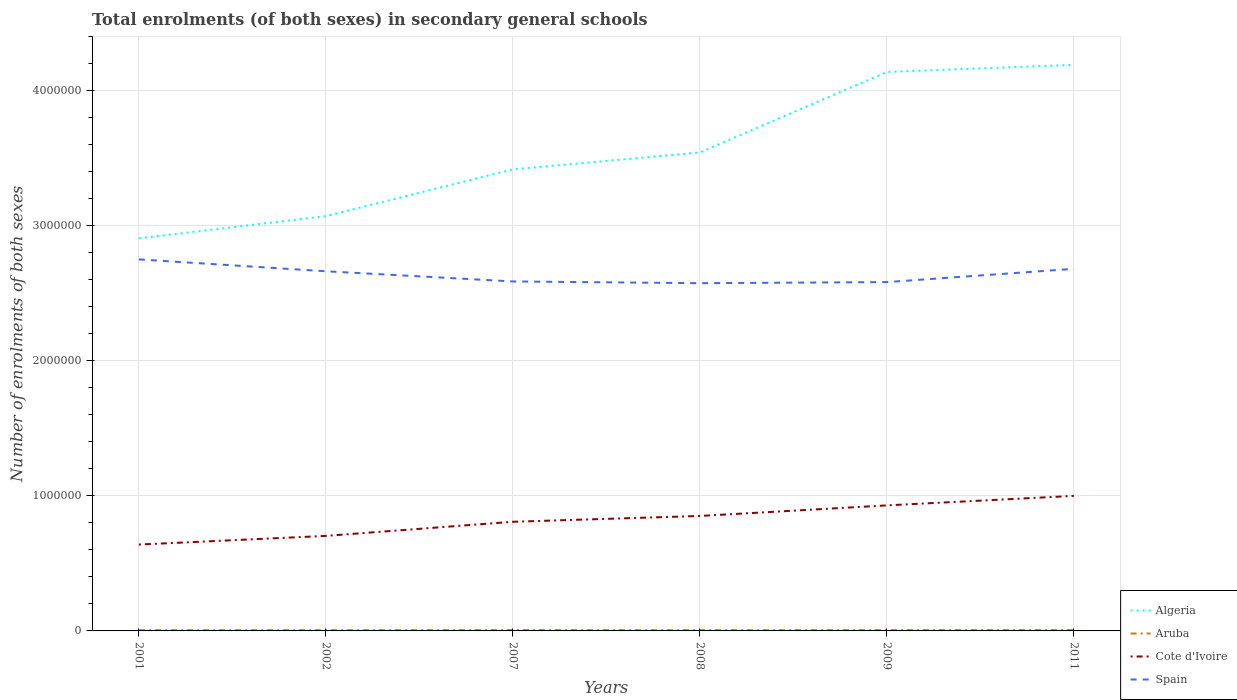Across all years, what is the maximum number of enrolments in secondary schools in Algeria?
Keep it short and to the point. 2.91e+06. In which year was the number of enrolments in secondary schools in Spain maximum?
Give a very brief answer. 2008. What is the total number of enrolments in secondary schools in Cote d'Ivoire in the graph?
Give a very brief answer. -6.43e+04. What is the difference between the highest and the second highest number of enrolments in secondary schools in Cote d'Ivoire?
Make the answer very short. 3.60e+05. How many years are there in the graph?
Make the answer very short. 6. Does the graph contain any zero values?
Provide a succinct answer. No. How many legend labels are there?
Give a very brief answer. 4. What is the title of the graph?
Keep it short and to the point. Total enrolments (of both sexes) in secondary general schools. What is the label or title of the X-axis?
Your answer should be very brief. Years. What is the label or title of the Y-axis?
Provide a short and direct response. Number of enrolments of both sexes. What is the Number of enrolments of both sexes of Algeria in 2001?
Keep it short and to the point. 2.91e+06. What is the Number of enrolments of both sexes of Aruba in 2001?
Give a very brief answer. 5352. What is the Number of enrolments of both sexes of Cote d'Ivoire in 2001?
Keep it short and to the point. 6.39e+05. What is the Number of enrolments of both sexes of Spain in 2001?
Your response must be concise. 2.75e+06. What is the Number of enrolments of both sexes of Algeria in 2002?
Keep it short and to the point. 3.07e+06. What is the Number of enrolments of both sexes in Aruba in 2002?
Ensure brevity in your answer.  5559. What is the Number of enrolments of both sexes in Cote d'Ivoire in 2002?
Your answer should be very brief. 7.04e+05. What is the Number of enrolments of both sexes in Spain in 2002?
Your answer should be compact. 2.66e+06. What is the Number of enrolments of both sexes in Algeria in 2007?
Ensure brevity in your answer.  3.42e+06. What is the Number of enrolments of both sexes in Aruba in 2007?
Give a very brief answer. 6339. What is the Number of enrolments of both sexes of Cote d'Ivoire in 2007?
Your response must be concise. 8.08e+05. What is the Number of enrolments of both sexes of Spain in 2007?
Provide a short and direct response. 2.59e+06. What is the Number of enrolments of both sexes of Algeria in 2008?
Give a very brief answer. 3.54e+06. What is the Number of enrolments of both sexes in Aruba in 2008?
Your response must be concise. 5921. What is the Number of enrolments of both sexes of Cote d'Ivoire in 2008?
Your answer should be very brief. 8.51e+05. What is the Number of enrolments of both sexes in Spain in 2008?
Provide a short and direct response. 2.57e+06. What is the Number of enrolments of both sexes in Algeria in 2009?
Ensure brevity in your answer.  4.14e+06. What is the Number of enrolments of both sexes of Aruba in 2009?
Give a very brief answer. 6201. What is the Number of enrolments of both sexes of Cote d'Ivoire in 2009?
Ensure brevity in your answer.  9.30e+05. What is the Number of enrolments of both sexes in Spain in 2009?
Your answer should be compact. 2.58e+06. What is the Number of enrolments of both sexes of Algeria in 2011?
Ensure brevity in your answer.  4.19e+06. What is the Number of enrolments of both sexes in Aruba in 2011?
Ensure brevity in your answer.  6281. What is the Number of enrolments of both sexes in Cote d'Ivoire in 2011?
Keep it short and to the point. 1.00e+06. What is the Number of enrolments of both sexes in Spain in 2011?
Your answer should be compact. 2.68e+06. Across all years, what is the maximum Number of enrolments of both sexes in Algeria?
Keep it short and to the point. 4.19e+06. Across all years, what is the maximum Number of enrolments of both sexes in Aruba?
Your answer should be compact. 6339. Across all years, what is the maximum Number of enrolments of both sexes of Cote d'Ivoire?
Offer a terse response. 1.00e+06. Across all years, what is the maximum Number of enrolments of both sexes of Spain?
Offer a terse response. 2.75e+06. Across all years, what is the minimum Number of enrolments of both sexes of Algeria?
Make the answer very short. 2.91e+06. Across all years, what is the minimum Number of enrolments of both sexes in Aruba?
Offer a terse response. 5352. Across all years, what is the minimum Number of enrolments of both sexes in Cote d'Ivoire?
Provide a short and direct response. 6.39e+05. Across all years, what is the minimum Number of enrolments of both sexes in Spain?
Offer a very short reply. 2.57e+06. What is the total Number of enrolments of both sexes of Algeria in the graph?
Your response must be concise. 2.13e+07. What is the total Number of enrolments of both sexes of Aruba in the graph?
Your answer should be compact. 3.57e+04. What is the total Number of enrolments of both sexes of Cote d'Ivoire in the graph?
Give a very brief answer. 4.93e+06. What is the total Number of enrolments of both sexes in Spain in the graph?
Your response must be concise. 1.58e+07. What is the difference between the Number of enrolments of both sexes in Algeria in 2001 and that in 2002?
Keep it short and to the point. -1.65e+05. What is the difference between the Number of enrolments of both sexes in Aruba in 2001 and that in 2002?
Offer a terse response. -207. What is the difference between the Number of enrolments of both sexes in Cote d'Ivoire in 2001 and that in 2002?
Provide a short and direct response. -6.43e+04. What is the difference between the Number of enrolments of both sexes in Spain in 2001 and that in 2002?
Keep it short and to the point. 8.80e+04. What is the difference between the Number of enrolments of both sexes of Algeria in 2001 and that in 2007?
Keep it short and to the point. -5.11e+05. What is the difference between the Number of enrolments of both sexes in Aruba in 2001 and that in 2007?
Make the answer very short. -987. What is the difference between the Number of enrolments of both sexes of Cote d'Ivoire in 2001 and that in 2007?
Give a very brief answer. -1.69e+05. What is the difference between the Number of enrolments of both sexes in Spain in 2001 and that in 2007?
Give a very brief answer. 1.63e+05. What is the difference between the Number of enrolments of both sexes in Algeria in 2001 and that in 2008?
Keep it short and to the point. -6.36e+05. What is the difference between the Number of enrolments of both sexes of Aruba in 2001 and that in 2008?
Offer a very short reply. -569. What is the difference between the Number of enrolments of both sexes of Cote d'Ivoire in 2001 and that in 2008?
Offer a terse response. -2.12e+05. What is the difference between the Number of enrolments of both sexes in Spain in 2001 and that in 2008?
Ensure brevity in your answer.  1.76e+05. What is the difference between the Number of enrolments of both sexes in Algeria in 2001 and that in 2009?
Your answer should be compact. -1.23e+06. What is the difference between the Number of enrolments of both sexes of Aruba in 2001 and that in 2009?
Make the answer very short. -849. What is the difference between the Number of enrolments of both sexes of Cote d'Ivoire in 2001 and that in 2009?
Provide a succinct answer. -2.90e+05. What is the difference between the Number of enrolments of both sexes of Spain in 2001 and that in 2009?
Make the answer very short. 1.68e+05. What is the difference between the Number of enrolments of both sexes in Algeria in 2001 and that in 2011?
Give a very brief answer. -1.28e+06. What is the difference between the Number of enrolments of both sexes of Aruba in 2001 and that in 2011?
Ensure brevity in your answer.  -929. What is the difference between the Number of enrolments of both sexes of Cote d'Ivoire in 2001 and that in 2011?
Ensure brevity in your answer.  -3.60e+05. What is the difference between the Number of enrolments of both sexes in Spain in 2001 and that in 2011?
Provide a short and direct response. 6.99e+04. What is the difference between the Number of enrolments of both sexes in Algeria in 2002 and that in 2007?
Offer a very short reply. -3.46e+05. What is the difference between the Number of enrolments of both sexes in Aruba in 2002 and that in 2007?
Provide a short and direct response. -780. What is the difference between the Number of enrolments of both sexes of Cote d'Ivoire in 2002 and that in 2007?
Ensure brevity in your answer.  -1.05e+05. What is the difference between the Number of enrolments of both sexes in Spain in 2002 and that in 2007?
Offer a very short reply. 7.54e+04. What is the difference between the Number of enrolments of both sexes of Algeria in 2002 and that in 2008?
Your response must be concise. -4.71e+05. What is the difference between the Number of enrolments of both sexes in Aruba in 2002 and that in 2008?
Offer a very short reply. -362. What is the difference between the Number of enrolments of both sexes in Cote d'Ivoire in 2002 and that in 2008?
Ensure brevity in your answer.  -1.48e+05. What is the difference between the Number of enrolments of both sexes in Spain in 2002 and that in 2008?
Your answer should be very brief. 8.82e+04. What is the difference between the Number of enrolments of both sexes of Algeria in 2002 and that in 2009?
Your answer should be very brief. -1.07e+06. What is the difference between the Number of enrolments of both sexes in Aruba in 2002 and that in 2009?
Provide a succinct answer. -642. What is the difference between the Number of enrolments of both sexes in Cote d'Ivoire in 2002 and that in 2009?
Your answer should be very brief. -2.26e+05. What is the difference between the Number of enrolments of both sexes in Spain in 2002 and that in 2009?
Provide a short and direct response. 8.02e+04. What is the difference between the Number of enrolments of both sexes in Algeria in 2002 and that in 2011?
Provide a succinct answer. -1.12e+06. What is the difference between the Number of enrolments of both sexes of Aruba in 2002 and that in 2011?
Offer a very short reply. -722. What is the difference between the Number of enrolments of both sexes of Cote d'Ivoire in 2002 and that in 2011?
Your answer should be compact. -2.96e+05. What is the difference between the Number of enrolments of both sexes of Spain in 2002 and that in 2011?
Ensure brevity in your answer.  -1.81e+04. What is the difference between the Number of enrolments of both sexes of Algeria in 2007 and that in 2008?
Offer a very short reply. -1.25e+05. What is the difference between the Number of enrolments of both sexes of Aruba in 2007 and that in 2008?
Offer a terse response. 418. What is the difference between the Number of enrolments of both sexes of Cote d'Ivoire in 2007 and that in 2008?
Offer a terse response. -4.30e+04. What is the difference between the Number of enrolments of both sexes of Spain in 2007 and that in 2008?
Give a very brief answer. 1.28e+04. What is the difference between the Number of enrolments of both sexes in Algeria in 2007 and that in 2009?
Your answer should be very brief. -7.21e+05. What is the difference between the Number of enrolments of both sexes in Aruba in 2007 and that in 2009?
Ensure brevity in your answer.  138. What is the difference between the Number of enrolments of both sexes in Cote d'Ivoire in 2007 and that in 2009?
Provide a succinct answer. -1.21e+05. What is the difference between the Number of enrolments of both sexes in Spain in 2007 and that in 2009?
Make the answer very short. 4835. What is the difference between the Number of enrolments of both sexes of Algeria in 2007 and that in 2011?
Ensure brevity in your answer.  -7.74e+05. What is the difference between the Number of enrolments of both sexes in Aruba in 2007 and that in 2011?
Provide a short and direct response. 58. What is the difference between the Number of enrolments of both sexes of Cote d'Ivoire in 2007 and that in 2011?
Give a very brief answer. -1.92e+05. What is the difference between the Number of enrolments of both sexes of Spain in 2007 and that in 2011?
Provide a short and direct response. -9.35e+04. What is the difference between the Number of enrolments of both sexes of Algeria in 2008 and that in 2009?
Provide a short and direct response. -5.96e+05. What is the difference between the Number of enrolments of both sexes in Aruba in 2008 and that in 2009?
Your answer should be very brief. -280. What is the difference between the Number of enrolments of both sexes in Cote d'Ivoire in 2008 and that in 2009?
Provide a succinct answer. -7.83e+04. What is the difference between the Number of enrolments of both sexes in Spain in 2008 and that in 2009?
Provide a short and direct response. -8005. What is the difference between the Number of enrolments of both sexes in Algeria in 2008 and that in 2011?
Give a very brief answer. -6.49e+05. What is the difference between the Number of enrolments of both sexes of Aruba in 2008 and that in 2011?
Provide a short and direct response. -360. What is the difference between the Number of enrolments of both sexes of Cote d'Ivoire in 2008 and that in 2011?
Offer a terse response. -1.49e+05. What is the difference between the Number of enrolments of both sexes of Spain in 2008 and that in 2011?
Keep it short and to the point. -1.06e+05. What is the difference between the Number of enrolments of both sexes of Algeria in 2009 and that in 2011?
Keep it short and to the point. -5.26e+04. What is the difference between the Number of enrolments of both sexes of Aruba in 2009 and that in 2011?
Your answer should be compact. -80. What is the difference between the Number of enrolments of both sexes of Cote d'Ivoire in 2009 and that in 2011?
Your response must be concise. -7.03e+04. What is the difference between the Number of enrolments of both sexes in Spain in 2009 and that in 2011?
Give a very brief answer. -9.83e+04. What is the difference between the Number of enrolments of both sexes in Algeria in 2001 and the Number of enrolments of both sexes in Aruba in 2002?
Your response must be concise. 2.90e+06. What is the difference between the Number of enrolments of both sexes in Algeria in 2001 and the Number of enrolments of both sexes in Cote d'Ivoire in 2002?
Offer a terse response. 2.20e+06. What is the difference between the Number of enrolments of both sexes of Algeria in 2001 and the Number of enrolments of both sexes of Spain in 2002?
Provide a short and direct response. 2.44e+05. What is the difference between the Number of enrolments of both sexes of Aruba in 2001 and the Number of enrolments of both sexes of Cote d'Ivoire in 2002?
Your answer should be compact. -6.98e+05. What is the difference between the Number of enrolments of both sexes in Aruba in 2001 and the Number of enrolments of both sexes in Spain in 2002?
Ensure brevity in your answer.  -2.66e+06. What is the difference between the Number of enrolments of both sexes of Cote d'Ivoire in 2001 and the Number of enrolments of both sexes of Spain in 2002?
Offer a very short reply. -2.02e+06. What is the difference between the Number of enrolments of both sexes of Algeria in 2001 and the Number of enrolments of both sexes of Aruba in 2007?
Provide a succinct answer. 2.90e+06. What is the difference between the Number of enrolments of both sexes in Algeria in 2001 and the Number of enrolments of both sexes in Cote d'Ivoire in 2007?
Your answer should be compact. 2.10e+06. What is the difference between the Number of enrolments of both sexes of Algeria in 2001 and the Number of enrolments of both sexes of Spain in 2007?
Make the answer very short. 3.19e+05. What is the difference between the Number of enrolments of both sexes of Aruba in 2001 and the Number of enrolments of both sexes of Cote d'Ivoire in 2007?
Keep it short and to the point. -8.03e+05. What is the difference between the Number of enrolments of both sexes of Aruba in 2001 and the Number of enrolments of both sexes of Spain in 2007?
Give a very brief answer. -2.58e+06. What is the difference between the Number of enrolments of both sexes of Cote d'Ivoire in 2001 and the Number of enrolments of both sexes of Spain in 2007?
Make the answer very short. -1.95e+06. What is the difference between the Number of enrolments of both sexes of Algeria in 2001 and the Number of enrolments of both sexes of Aruba in 2008?
Keep it short and to the point. 2.90e+06. What is the difference between the Number of enrolments of both sexes of Algeria in 2001 and the Number of enrolments of both sexes of Cote d'Ivoire in 2008?
Offer a terse response. 2.06e+06. What is the difference between the Number of enrolments of both sexes in Algeria in 2001 and the Number of enrolments of both sexes in Spain in 2008?
Offer a terse response. 3.32e+05. What is the difference between the Number of enrolments of both sexes of Aruba in 2001 and the Number of enrolments of both sexes of Cote d'Ivoire in 2008?
Offer a terse response. -8.46e+05. What is the difference between the Number of enrolments of both sexes of Aruba in 2001 and the Number of enrolments of both sexes of Spain in 2008?
Your answer should be very brief. -2.57e+06. What is the difference between the Number of enrolments of both sexes in Cote d'Ivoire in 2001 and the Number of enrolments of both sexes in Spain in 2008?
Provide a short and direct response. -1.94e+06. What is the difference between the Number of enrolments of both sexes in Algeria in 2001 and the Number of enrolments of both sexes in Aruba in 2009?
Ensure brevity in your answer.  2.90e+06. What is the difference between the Number of enrolments of both sexes of Algeria in 2001 and the Number of enrolments of both sexes of Cote d'Ivoire in 2009?
Offer a terse response. 1.98e+06. What is the difference between the Number of enrolments of both sexes in Algeria in 2001 and the Number of enrolments of both sexes in Spain in 2009?
Provide a succinct answer. 3.24e+05. What is the difference between the Number of enrolments of both sexes in Aruba in 2001 and the Number of enrolments of both sexes in Cote d'Ivoire in 2009?
Your answer should be very brief. -9.24e+05. What is the difference between the Number of enrolments of both sexes of Aruba in 2001 and the Number of enrolments of both sexes of Spain in 2009?
Your answer should be very brief. -2.58e+06. What is the difference between the Number of enrolments of both sexes of Cote d'Ivoire in 2001 and the Number of enrolments of both sexes of Spain in 2009?
Ensure brevity in your answer.  -1.94e+06. What is the difference between the Number of enrolments of both sexes of Algeria in 2001 and the Number of enrolments of both sexes of Aruba in 2011?
Provide a short and direct response. 2.90e+06. What is the difference between the Number of enrolments of both sexes of Algeria in 2001 and the Number of enrolments of both sexes of Cote d'Ivoire in 2011?
Keep it short and to the point. 1.91e+06. What is the difference between the Number of enrolments of both sexes in Algeria in 2001 and the Number of enrolments of both sexes in Spain in 2011?
Provide a short and direct response. 2.25e+05. What is the difference between the Number of enrolments of both sexes in Aruba in 2001 and the Number of enrolments of both sexes in Cote d'Ivoire in 2011?
Provide a short and direct response. -9.95e+05. What is the difference between the Number of enrolments of both sexes in Aruba in 2001 and the Number of enrolments of both sexes in Spain in 2011?
Ensure brevity in your answer.  -2.68e+06. What is the difference between the Number of enrolments of both sexes in Cote d'Ivoire in 2001 and the Number of enrolments of both sexes in Spain in 2011?
Make the answer very short. -2.04e+06. What is the difference between the Number of enrolments of both sexes in Algeria in 2002 and the Number of enrolments of both sexes in Aruba in 2007?
Keep it short and to the point. 3.07e+06. What is the difference between the Number of enrolments of both sexes of Algeria in 2002 and the Number of enrolments of both sexes of Cote d'Ivoire in 2007?
Your response must be concise. 2.26e+06. What is the difference between the Number of enrolments of both sexes in Algeria in 2002 and the Number of enrolments of both sexes in Spain in 2007?
Ensure brevity in your answer.  4.84e+05. What is the difference between the Number of enrolments of both sexes of Aruba in 2002 and the Number of enrolments of both sexes of Cote d'Ivoire in 2007?
Make the answer very short. -8.03e+05. What is the difference between the Number of enrolments of both sexes in Aruba in 2002 and the Number of enrolments of both sexes in Spain in 2007?
Provide a short and direct response. -2.58e+06. What is the difference between the Number of enrolments of both sexes in Cote d'Ivoire in 2002 and the Number of enrolments of both sexes in Spain in 2007?
Offer a very short reply. -1.88e+06. What is the difference between the Number of enrolments of both sexes of Algeria in 2002 and the Number of enrolments of both sexes of Aruba in 2008?
Offer a terse response. 3.07e+06. What is the difference between the Number of enrolments of both sexes in Algeria in 2002 and the Number of enrolments of both sexes in Cote d'Ivoire in 2008?
Keep it short and to the point. 2.22e+06. What is the difference between the Number of enrolments of both sexes of Algeria in 2002 and the Number of enrolments of both sexes of Spain in 2008?
Give a very brief answer. 4.97e+05. What is the difference between the Number of enrolments of both sexes of Aruba in 2002 and the Number of enrolments of both sexes of Cote d'Ivoire in 2008?
Offer a very short reply. -8.46e+05. What is the difference between the Number of enrolments of both sexes of Aruba in 2002 and the Number of enrolments of both sexes of Spain in 2008?
Offer a very short reply. -2.57e+06. What is the difference between the Number of enrolments of both sexes of Cote d'Ivoire in 2002 and the Number of enrolments of both sexes of Spain in 2008?
Provide a short and direct response. -1.87e+06. What is the difference between the Number of enrolments of both sexes in Algeria in 2002 and the Number of enrolments of both sexes in Aruba in 2009?
Provide a succinct answer. 3.07e+06. What is the difference between the Number of enrolments of both sexes in Algeria in 2002 and the Number of enrolments of both sexes in Cote d'Ivoire in 2009?
Make the answer very short. 2.14e+06. What is the difference between the Number of enrolments of both sexes in Algeria in 2002 and the Number of enrolments of both sexes in Spain in 2009?
Provide a succinct answer. 4.89e+05. What is the difference between the Number of enrolments of both sexes of Aruba in 2002 and the Number of enrolments of both sexes of Cote d'Ivoire in 2009?
Offer a very short reply. -9.24e+05. What is the difference between the Number of enrolments of both sexes in Aruba in 2002 and the Number of enrolments of both sexes in Spain in 2009?
Your answer should be very brief. -2.58e+06. What is the difference between the Number of enrolments of both sexes in Cote d'Ivoire in 2002 and the Number of enrolments of both sexes in Spain in 2009?
Provide a short and direct response. -1.88e+06. What is the difference between the Number of enrolments of both sexes of Algeria in 2002 and the Number of enrolments of both sexes of Aruba in 2011?
Offer a terse response. 3.07e+06. What is the difference between the Number of enrolments of both sexes in Algeria in 2002 and the Number of enrolments of both sexes in Cote d'Ivoire in 2011?
Give a very brief answer. 2.07e+06. What is the difference between the Number of enrolments of both sexes in Algeria in 2002 and the Number of enrolments of both sexes in Spain in 2011?
Keep it short and to the point. 3.90e+05. What is the difference between the Number of enrolments of both sexes in Aruba in 2002 and the Number of enrolments of both sexes in Cote d'Ivoire in 2011?
Your answer should be very brief. -9.94e+05. What is the difference between the Number of enrolments of both sexes of Aruba in 2002 and the Number of enrolments of both sexes of Spain in 2011?
Provide a succinct answer. -2.68e+06. What is the difference between the Number of enrolments of both sexes of Cote d'Ivoire in 2002 and the Number of enrolments of both sexes of Spain in 2011?
Provide a succinct answer. -1.98e+06. What is the difference between the Number of enrolments of both sexes in Algeria in 2007 and the Number of enrolments of both sexes in Aruba in 2008?
Ensure brevity in your answer.  3.41e+06. What is the difference between the Number of enrolments of both sexes in Algeria in 2007 and the Number of enrolments of both sexes in Cote d'Ivoire in 2008?
Provide a short and direct response. 2.57e+06. What is the difference between the Number of enrolments of both sexes of Algeria in 2007 and the Number of enrolments of both sexes of Spain in 2008?
Keep it short and to the point. 8.43e+05. What is the difference between the Number of enrolments of both sexes of Aruba in 2007 and the Number of enrolments of both sexes of Cote d'Ivoire in 2008?
Ensure brevity in your answer.  -8.45e+05. What is the difference between the Number of enrolments of both sexes in Aruba in 2007 and the Number of enrolments of both sexes in Spain in 2008?
Offer a very short reply. -2.57e+06. What is the difference between the Number of enrolments of both sexes in Cote d'Ivoire in 2007 and the Number of enrolments of both sexes in Spain in 2008?
Ensure brevity in your answer.  -1.77e+06. What is the difference between the Number of enrolments of both sexes in Algeria in 2007 and the Number of enrolments of both sexes in Aruba in 2009?
Make the answer very short. 3.41e+06. What is the difference between the Number of enrolments of both sexes of Algeria in 2007 and the Number of enrolments of both sexes of Cote d'Ivoire in 2009?
Give a very brief answer. 2.49e+06. What is the difference between the Number of enrolments of both sexes in Algeria in 2007 and the Number of enrolments of both sexes in Spain in 2009?
Your response must be concise. 8.35e+05. What is the difference between the Number of enrolments of both sexes of Aruba in 2007 and the Number of enrolments of both sexes of Cote d'Ivoire in 2009?
Provide a short and direct response. -9.23e+05. What is the difference between the Number of enrolments of both sexes in Aruba in 2007 and the Number of enrolments of both sexes in Spain in 2009?
Your answer should be compact. -2.58e+06. What is the difference between the Number of enrolments of both sexes of Cote d'Ivoire in 2007 and the Number of enrolments of both sexes of Spain in 2009?
Provide a succinct answer. -1.77e+06. What is the difference between the Number of enrolments of both sexes in Algeria in 2007 and the Number of enrolments of both sexes in Aruba in 2011?
Your response must be concise. 3.41e+06. What is the difference between the Number of enrolments of both sexes in Algeria in 2007 and the Number of enrolments of both sexes in Cote d'Ivoire in 2011?
Your response must be concise. 2.42e+06. What is the difference between the Number of enrolments of both sexes in Algeria in 2007 and the Number of enrolments of both sexes in Spain in 2011?
Provide a succinct answer. 7.36e+05. What is the difference between the Number of enrolments of both sexes in Aruba in 2007 and the Number of enrolments of both sexes in Cote d'Ivoire in 2011?
Give a very brief answer. -9.94e+05. What is the difference between the Number of enrolments of both sexes of Aruba in 2007 and the Number of enrolments of both sexes of Spain in 2011?
Keep it short and to the point. -2.67e+06. What is the difference between the Number of enrolments of both sexes of Cote d'Ivoire in 2007 and the Number of enrolments of both sexes of Spain in 2011?
Provide a succinct answer. -1.87e+06. What is the difference between the Number of enrolments of both sexes in Algeria in 2008 and the Number of enrolments of both sexes in Aruba in 2009?
Give a very brief answer. 3.54e+06. What is the difference between the Number of enrolments of both sexes in Algeria in 2008 and the Number of enrolments of both sexes in Cote d'Ivoire in 2009?
Provide a succinct answer. 2.61e+06. What is the difference between the Number of enrolments of both sexes in Algeria in 2008 and the Number of enrolments of both sexes in Spain in 2009?
Your response must be concise. 9.60e+05. What is the difference between the Number of enrolments of both sexes in Aruba in 2008 and the Number of enrolments of both sexes in Cote d'Ivoire in 2009?
Give a very brief answer. -9.24e+05. What is the difference between the Number of enrolments of both sexes in Aruba in 2008 and the Number of enrolments of both sexes in Spain in 2009?
Offer a terse response. -2.58e+06. What is the difference between the Number of enrolments of both sexes of Cote d'Ivoire in 2008 and the Number of enrolments of both sexes of Spain in 2009?
Your response must be concise. -1.73e+06. What is the difference between the Number of enrolments of both sexes of Algeria in 2008 and the Number of enrolments of both sexes of Aruba in 2011?
Your answer should be very brief. 3.54e+06. What is the difference between the Number of enrolments of both sexes in Algeria in 2008 and the Number of enrolments of both sexes in Cote d'Ivoire in 2011?
Your response must be concise. 2.54e+06. What is the difference between the Number of enrolments of both sexes in Algeria in 2008 and the Number of enrolments of both sexes in Spain in 2011?
Your answer should be very brief. 8.62e+05. What is the difference between the Number of enrolments of both sexes in Aruba in 2008 and the Number of enrolments of both sexes in Cote d'Ivoire in 2011?
Provide a succinct answer. -9.94e+05. What is the difference between the Number of enrolments of both sexes in Aruba in 2008 and the Number of enrolments of both sexes in Spain in 2011?
Your answer should be compact. -2.68e+06. What is the difference between the Number of enrolments of both sexes of Cote d'Ivoire in 2008 and the Number of enrolments of both sexes of Spain in 2011?
Provide a succinct answer. -1.83e+06. What is the difference between the Number of enrolments of both sexes of Algeria in 2009 and the Number of enrolments of both sexes of Aruba in 2011?
Give a very brief answer. 4.13e+06. What is the difference between the Number of enrolments of both sexes of Algeria in 2009 and the Number of enrolments of both sexes of Cote d'Ivoire in 2011?
Provide a succinct answer. 3.14e+06. What is the difference between the Number of enrolments of both sexes in Algeria in 2009 and the Number of enrolments of both sexes in Spain in 2011?
Your answer should be very brief. 1.46e+06. What is the difference between the Number of enrolments of both sexes in Aruba in 2009 and the Number of enrolments of both sexes in Cote d'Ivoire in 2011?
Offer a terse response. -9.94e+05. What is the difference between the Number of enrolments of both sexes of Aruba in 2009 and the Number of enrolments of both sexes of Spain in 2011?
Keep it short and to the point. -2.68e+06. What is the difference between the Number of enrolments of both sexes of Cote d'Ivoire in 2009 and the Number of enrolments of both sexes of Spain in 2011?
Your answer should be very brief. -1.75e+06. What is the average Number of enrolments of both sexes in Algeria per year?
Your answer should be very brief. 3.54e+06. What is the average Number of enrolments of both sexes of Aruba per year?
Your answer should be very brief. 5942.17. What is the average Number of enrolments of both sexes of Cote d'Ivoire per year?
Make the answer very short. 8.22e+05. What is the average Number of enrolments of both sexes in Spain per year?
Offer a very short reply. 2.64e+06. In the year 2001, what is the difference between the Number of enrolments of both sexes of Algeria and Number of enrolments of both sexes of Aruba?
Offer a terse response. 2.90e+06. In the year 2001, what is the difference between the Number of enrolments of both sexes in Algeria and Number of enrolments of both sexes in Cote d'Ivoire?
Your response must be concise. 2.27e+06. In the year 2001, what is the difference between the Number of enrolments of both sexes in Algeria and Number of enrolments of both sexes in Spain?
Make the answer very short. 1.56e+05. In the year 2001, what is the difference between the Number of enrolments of both sexes in Aruba and Number of enrolments of both sexes in Cote d'Ivoire?
Your response must be concise. -6.34e+05. In the year 2001, what is the difference between the Number of enrolments of both sexes in Aruba and Number of enrolments of both sexes in Spain?
Ensure brevity in your answer.  -2.75e+06. In the year 2001, what is the difference between the Number of enrolments of both sexes in Cote d'Ivoire and Number of enrolments of both sexes in Spain?
Offer a very short reply. -2.11e+06. In the year 2002, what is the difference between the Number of enrolments of both sexes in Algeria and Number of enrolments of both sexes in Aruba?
Ensure brevity in your answer.  3.07e+06. In the year 2002, what is the difference between the Number of enrolments of both sexes of Algeria and Number of enrolments of both sexes of Cote d'Ivoire?
Offer a very short reply. 2.37e+06. In the year 2002, what is the difference between the Number of enrolments of both sexes in Algeria and Number of enrolments of both sexes in Spain?
Your response must be concise. 4.09e+05. In the year 2002, what is the difference between the Number of enrolments of both sexes in Aruba and Number of enrolments of both sexes in Cote d'Ivoire?
Your answer should be compact. -6.98e+05. In the year 2002, what is the difference between the Number of enrolments of both sexes of Aruba and Number of enrolments of both sexes of Spain?
Your response must be concise. -2.66e+06. In the year 2002, what is the difference between the Number of enrolments of both sexes in Cote d'Ivoire and Number of enrolments of both sexes in Spain?
Your response must be concise. -1.96e+06. In the year 2007, what is the difference between the Number of enrolments of both sexes in Algeria and Number of enrolments of both sexes in Aruba?
Provide a short and direct response. 3.41e+06. In the year 2007, what is the difference between the Number of enrolments of both sexes in Algeria and Number of enrolments of both sexes in Cote d'Ivoire?
Make the answer very short. 2.61e+06. In the year 2007, what is the difference between the Number of enrolments of both sexes in Algeria and Number of enrolments of both sexes in Spain?
Your answer should be compact. 8.30e+05. In the year 2007, what is the difference between the Number of enrolments of both sexes of Aruba and Number of enrolments of both sexes of Cote d'Ivoire?
Make the answer very short. -8.02e+05. In the year 2007, what is the difference between the Number of enrolments of both sexes of Aruba and Number of enrolments of both sexes of Spain?
Make the answer very short. -2.58e+06. In the year 2007, what is the difference between the Number of enrolments of both sexes in Cote d'Ivoire and Number of enrolments of both sexes in Spain?
Offer a very short reply. -1.78e+06. In the year 2008, what is the difference between the Number of enrolments of both sexes in Algeria and Number of enrolments of both sexes in Aruba?
Your response must be concise. 3.54e+06. In the year 2008, what is the difference between the Number of enrolments of both sexes of Algeria and Number of enrolments of both sexes of Cote d'Ivoire?
Offer a terse response. 2.69e+06. In the year 2008, what is the difference between the Number of enrolments of both sexes of Algeria and Number of enrolments of both sexes of Spain?
Provide a short and direct response. 9.68e+05. In the year 2008, what is the difference between the Number of enrolments of both sexes of Aruba and Number of enrolments of both sexes of Cote d'Ivoire?
Your response must be concise. -8.45e+05. In the year 2008, what is the difference between the Number of enrolments of both sexes of Aruba and Number of enrolments of both sexes of Spain?
Offer a very short reply. -2.57e+06. In the year 2008, what is the difference between the Number of enrolments of both sexes in Cote d'Ivoire and Number of enrolments of both sexes in Spain?
Your answer should be compact. -1.72e+06. In the year 2009, what is the difference between the Number of enrolments of both sexes of Algeria and Number of enrolments of both sexes of Aruba?
Give a very brief answer. 4.13e+06. In the year 2009, what is the difference between the Number of enrolments of both sexes of Algeria and Number of enrolments of both sexes of Cote d'Ivoire?
Your answer should be compact. 3.21e+06. In the year 2009, what is the difference between the Number of enrolments of both sexes of Algeria and Number of enrolments of both sexes of Spain?
Offer a terse response. 1.56e+06. In the year 2009, what is the difference between the Number of enrolments of both sexes of Aruba and Number of enrolments of both sexes of Cote d'Ivoire?
Give a very brief answer. -9.23e+05. In the year 2009, what is the difference between the Number of enrolments of both sexes of Aruba and Number of enrolments of both sexes of Spain?
Make the answer very short. -2.58e+06. In the year 2009, what is the difference between the Number of enrolments of both sexes in Cote d'Ivoire and Number of enrolments of both sexes in Spain?
Offer a very short reply. -1.65e+06. In the year 2011, what is the difference between the Number of enrolments of both sexes of Algeria and Number of enrolments of both sexes of Aruba?
Make the answer very short. 4.19e+06. In the year 2011, what is the difference between the Number of enrolments of both sexes in Algeria and Number of enrolments of both sexes in Cote d'Ivoire?
Provide a succinct answer. 3.19e+06. In the year 2011, what is the difference between the Number of enrolments of both sexes of Algeria and Number of enrolments of both sexes of Spain?
Offer a terse response. 1.51e+06. In the year 2011, what is the difference between the Number of enrolments of both sexes of Aruba and Number of enrolments of both sexes of Cote d'Ivoire?
Offer a terse response. -9.94e+05. In the year 2011, what is the difference between the Number of enrolments of both sexes of Aruba and Number of enrolments of both sexes of Spain?
Make the answer very short. -2.67e+06. In the year 2011, what is the difference between the Number of enrolments of both sexes of Cote d'Ivoire and Number of enrolments of both sexes of Spain?
Give a very brief answer. -1.68e+06. What is the ratio of the Number of enrolments of both sexes in Algeria in 2001 to that in 2002?
Ensure brevity in your answer.  0.95. What is the ratio of the Number of enrolments of both sexes of Aruba in 2001 to that in 2002?
Your response must be concise. 0.96. What is the ratio of the Number of enrolments of both sexes of Cote d'Ivoire in 2001 to that in 2002?
Your answer should be very brief. 0.91. What is the ratio of the Number of enrolments of both sexes in Spain in 2001 to that in 2002?
Your answer should be compact. 1.03. What is the ratio of the Number of enrolments of both sexes in Algeria in 2001 to that in 2007?
Offer a very short reply. 0.85. What is the ratio of the Number of enrolments of both sexes in Aruba in 2001 to that in 2007?
Make the answer very short. 0.84. What is the ratio of the Number of enrolments of both sexes of Cote d'Ivoire in 2001 to that in 2007?
Offer a very short reply. 0.79. What is the ratio of the Number of enrolments of both sexes in Spain in 2001 to that in 2007?
Your answer should be very brief. 1.06. What is the ratio of the Number of enrolments of both sexes in Algeria in 2001 to that in 2008?
Keep it short and to the point. 0.82. What is the ratio of the Number of enrolments of both sexes in Aruba in 2001 to that in 2008?
Give a very brief answer. 0.9. What is the ratio of the Number of enrolments of both sexes in Cote d'Ivoire in 2001 to that in 2008?
Your response must be concise. 0.75. What is the ratio of the Number of enrolments of both sexes in Spain in 2001 to that in 2008?
Provide a short and direct response. 1.07. What is the ratio of the Number of enrolments of both sexes of Algeria in 2001 to that in 2009?
Your answer should be compact. 0.7. What is the ratio of the Number of enrolments of both sexes of Aruba in 2001 to that in 2009?
Offer a very short reply. 0.86. What is the ratio of the Number of enrolments of both sexes of Cote d'Ivoire in 2001 to that in 2009?
Provide a succinct answer. 0.69. What is the ratio of the Number of enrolments of both sexes in Spain in 2001 to that in 2009?
Your answer should be compact. 1.07. What is the ratio of the Number of enrolments of both sexes in Algeria in 2001 to that in 2011?
Make the answer very short. 0.69. What is the ratio of the Number of enrolments of both sexes of Aruba in 2001 to that in 2011?
Give a very brief answer. 0.85. What is the ratio of the Number of enrolments of both sexes of Cote d'Ivoire in 2001 to that in 2011?
Offer a terse response. 0.64. What is the ratio of the Number of enrolments of both sexes in Spain in 2001 to that in 2011?
Offer a terse response. 1.03. What is the ratio of the Number of enrolments of both sexes in Algeria in 2002 to that in 2007?
Give a very brief answer. 0.9. What is the ratio of the Number of enrolments of both sexes of Aruba in 2002 to that in 2007?
Offer a terse response. 0.88. What is the ratio of the Number of enrolments of both sexes in Cote d'Ivoire in 2002 to that in 2007?
Make the answer very short. 0.87. What is the ratio of the Number of enrolments of both sexes in Spain in 2002 to that in 2007?
Your answer should be very brief. 1.03. What is the ratio of the Number of enrolments of both sexes in Algeria in 2002 to that in 2008?
Your answer should be very brief. 0.87. What is the ratio of the Number of enrolments of both sexes in Aruba in 2002 to that in 2008?
Keep it short and to the point. 0.94. What is the ratio of the Number of enrolments of both sexes of Cote d'Ivoire in 2002 to that in 2008?
Give a very brief answer. 0.83. What is the ratio of the Number of enrolments of both sexes in Spain in 2002 to that in 2008?
Ensure brevity in your answer.  1.03. What is the ratio of the Number of enrolments of both sexes in Algeria in 2002 to that in 2009?
Offer a terse response. 0.74. What is the ratio of the Number of enrolments of both sexes in Aruba in 2002 to that in 2009?
Give a very brief answer. 0.9. What is the ratio of the Number of enrolments of both sexes in Cote d'Ivoire in 2002 to that in 2009?
Give a very brief answer. 0.76. What is the ratio of the Number of enrolments of both sexes in Spain in 2002 to that in 2009?
Provide a succinct answer. 1.03. What is the ratio of the Number of enrolments of both sexes in Algeria in 2002 to that in 2011?
Give a very brief answer. 0.73. What is the ratio of the Number of enrolments of both sexes in Aruba in 2002 to that in 2011?
Your answer should be very brief. 0.89. What is the ratio of the Number of enrolments of both sexes of Cote d'Ivoire in 2002 to that in 2011?
Ensure brevity in your answer.  0.7. What is the ratio of the Number of enrolments of both sexes in Spain in 2002 to that in 2011?
Offer a very short reply. 0.99. What is the ratio of the Number of enrolments of both sexes in Algeria in 2007 to that in 2008?
Offer a very short reply. 0.96. What is the ratio of the Number of enrolments of both sexes of Aruba in 2007 to that in 2008?
Offer a terse response. 1.07. What is the ratio of the Number of enrolments of both sexes of Cote d'Ivoire in 2007 to that in 2008?
Offer a terse response. 0.95. What is the ratio of the Number of enrolments of both sexes of Spain in 2007 to that in 2008?
Make the answer very short. 1. What is the ratio of the Number of enrolments of both sexes in Algeria in 2007 to that in 2009?
Provide a succinct answer. 0.83. What is the ratio of the Number of enrolments of both sexes of Aruba in 2007 to that in 2009?
Offer a very short reply. 1.02. What is the ratio of the Number of enrolments of both sexes in Cote d'Ivoire in 2007 to that in 2009?
Keep it short and to the point. 0.87. What is the ratio of the Number of enrolments of both sexes in Spain in 2007 to that in 2009?
Your response must be concise. 1. What is the ratio of the Number of enrolments of both sexes of Algeria in 2007 to that in 2011?
Offer a terse response. 0.82. What is the ratio of the Number of enrolments of both sexes of Aruba in 2007 to that in 2011?
Provide a succinct answer. 1.01. What is the ratio of the Number of enrolments of both sexes in Cote d'Ivoire in 2007 to that in 2011?
Provide a short and direct response. 0.81. What is the ratio of the Number of enrolments of both sexes of Spain in 2007 to that in 2011?
Make the answer very short. 0.97. What is the ratio of the Number of enrolments of both sexes in Algeria in 2008 to that in 2009?
Provide a succinct answer. 0.86. What is the ratio of the Number of enrolments of both sexes in Aruba in 2008 to that in 2009?
Make the answer very short. 0.95. What is the ratio of the Number of enrolments of both sexes of Cote d'Ivoire in 2008 to that in 2009?
Give a very brief answer. 0.92. What is the ratio of the Number of enrolments of both sexes in Algeria in 2008 to that in 2011?
Keep it short and to the point. 0.85. What is the ratio of the Number of enrolments of both sexes of Aruba in 2008 to that in 2011?
Offer a terse response. 0.94. What is the ratio of the Number of enrolments of both sexes in Cote d'Ivoire in 2008 to that in 2011?
Provide a short and direct response. 0.85. What is the ratio of the Number of enrolments of both sexes of Spain in 2008 to that in 2011?
Keep it short and to the point. 0.96. What is the ratio of the Number of enrolments of both sexes of Algeria in 2009 to that in 2011?
Keep it short and to the point. 0.99. What is the ratio of the Number of enrolments of both sexes of Aruba in 2009 to that in 2011?
Make the answer very short. 0.99. What is the ratio of the Number of enrolments of both sexes of Cote d'Ivoire in 2009 to that in 2011?
Provide a succinct answer. 0.93. What is the ratio of the Number of enrolments of both sexes of Spain in 2009 to that in 2011?
Give a very brief answer. 0.96. What is the difference between the highest and the second highest Number of enrolments of both sexes in Algeria?
Give a very brief answer. 5.26e+04. What is the difference between the highest and the second highest Number of enrolments of both sexes of Aruba?
Ensure brevity in your answer.  58. What is the difference between the highest and the second highest Number of enrolments of both sexes of Cote d'Ivoire?
Keep it short and to the point. 7.03e+04. What is the difference between the highest and the second highest Number of enrolments of both sexes of Spain?
Provide a succinct answer. 6.99e+04. What is the difference between the highest and the lowest Number of enrolments of both sexes in Algeria?
Offer a very short reply. 1.28e+06. What is the difference between the highest and the lowest Number of enrolments of both sexes in Aruba?
Give a very brief answer. 987. What is the difference between the highest and the lowest Number of enrolments of both sexes of Cote d'Ivoire?
Offer a very short reply. 3.60e+05. What is the difference between the highest and the lowest Number of enrolments of both sexes in Spain?
Ensure brevity in your answer.  1.76e+05. 